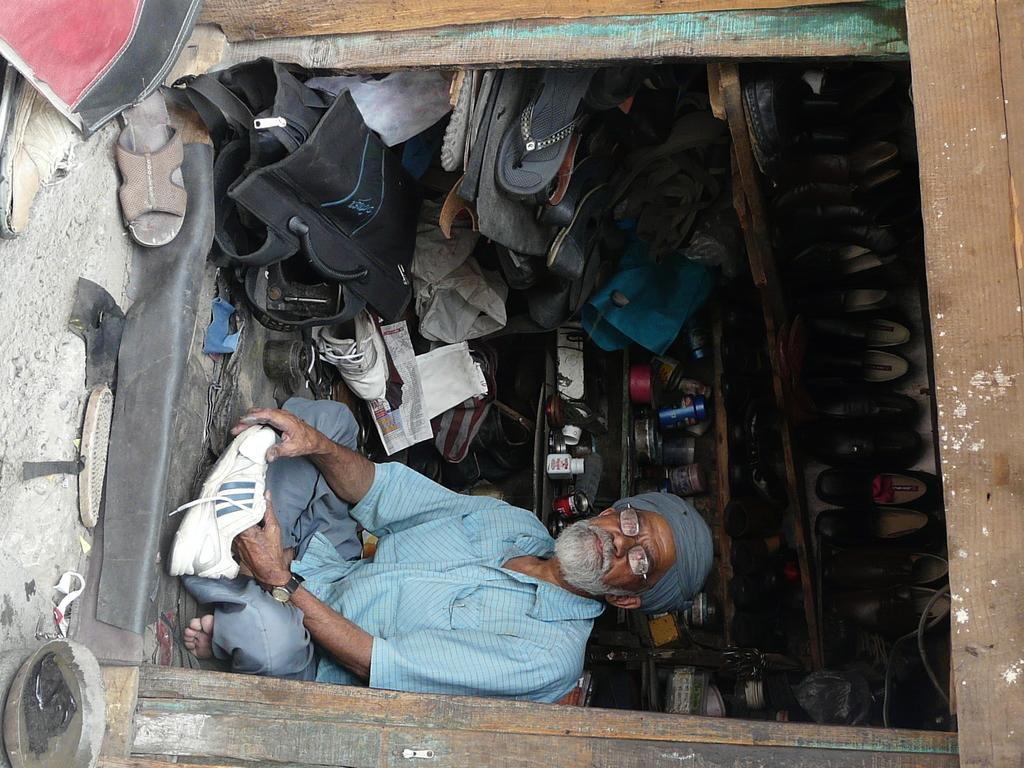What type of establishment is depicted in the image? There is a small shop in the image. What kind of products are available in the shop? The shop is full of footwear. Is there anyone present in the shop? Yes, there is a man sitting in the shop. What is the man doing in the image? The man is holding a shoe. How many fingers can be seen on the man's hand holding the shoe in the image? There is no information about the man's fingers in the image, as it only shows him holding a shoe. 